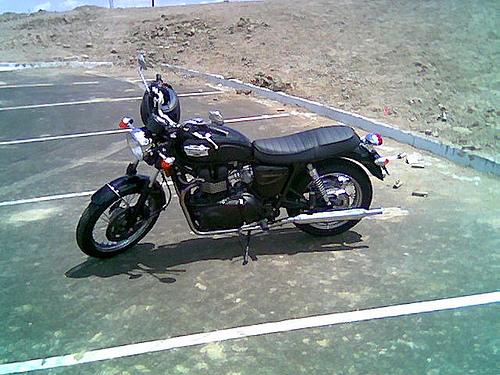What brand of bike is this bike?
Concise answer only. Harley davidson. What did the rider of this bike do with their helmet?
Quick response, please. Hang on bike. Is this bike parked properly?
Be succinct. Yes. 